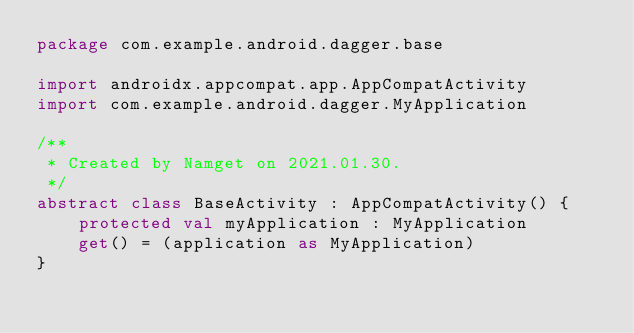<code> <loc_0><loc_0><loc_500><loc_500><_Kotlin_>package com.example.android.dagger.base

import androidx.appcompat.app.AppCompatActivity
import com.example.android.dagger.MyApplication

/**
 * Created by Namget on 2021.01.30.
 */
abstract class BaseActivity : AppCompatActivity() {
    protected val myApplication : MyApplication
    get() = (application as MyApplication)
}</code> 